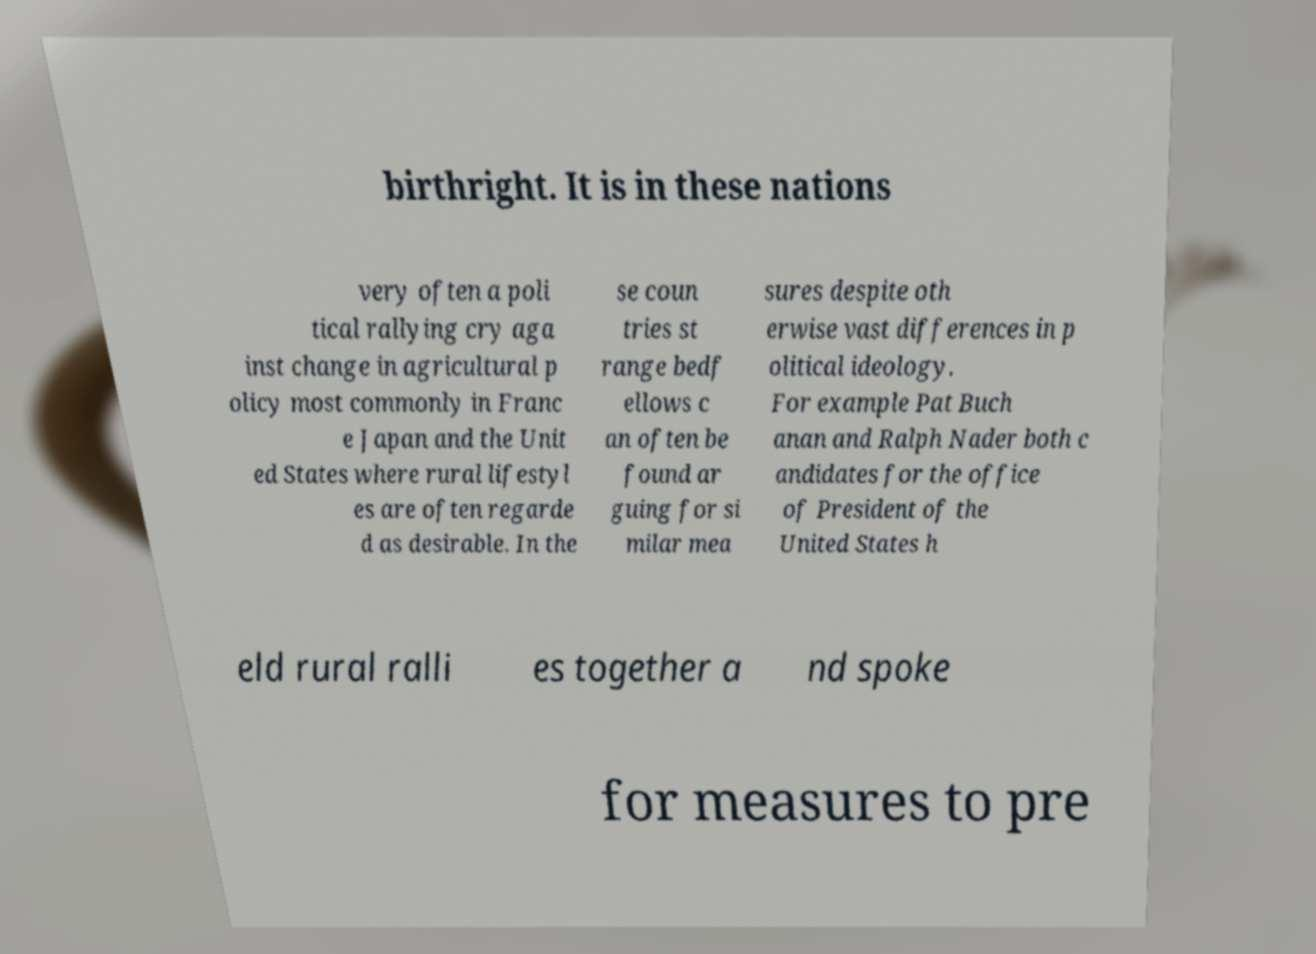Please identify and transcribe the text found in this image. birthright. It is in these nations very often a poli tical rallying cry aga inst change in agricultural p olicy most commonly in Franc e Japan and the Unit ed States where rural lifestyl es are often regarde d as desirable. In the se coun tries st range bedf ellows c an often be found ar guing for si milar mea sures despite oth erwise vast differences in p olitical ideology. For example Pat Buch anan and Ralph Nader both c andidates for the office of President of the United States h eld rural ralli es together a nd spoke for measures to pre 